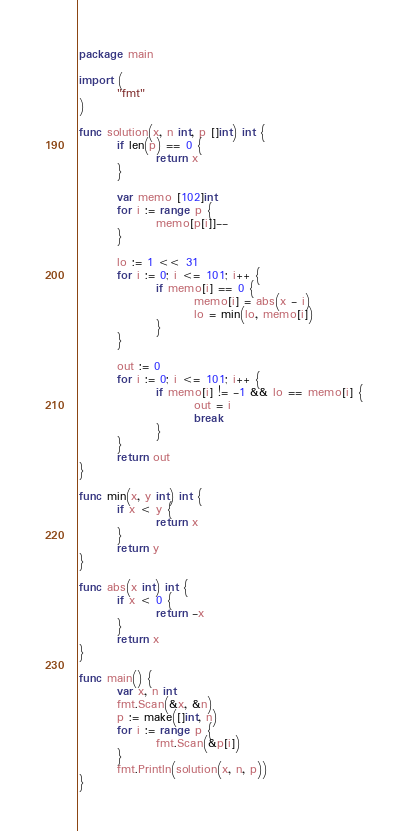<code> <loc_0><loc_0><loc_500><loc_500><_Go_>package main

import (
        "fmt"
)

func solution(x, n int, p []int) int {
        if len(p) == 0 {
                return x
        }

        var memo [102]int
        for i := range p {
                memo[p[i]]--
        }

        lo := 1 << 31
        for i := 0; i <= 101; i++ {
                if memo[i] == 0 {
                        memo[i] = abs(x - i)
                        lo = min(lo, memo[i])
                }
        }

        out := 0
        for i := 0; i <= 101; i++ {
                if memo[i] != -1 && lo == memo[i] {
                        out = i
                        break
                }
        }
        return out
}

func min(x, y int) int {
        if x < y {
                return x
        }
        return y
}

func abs(x int) int {
        if x < 0 {
                return -x
        }
        return x
}

func main() {
        var x, n int
        fmt.Scan(&x, &n)
        p := make([]int, n)
        for i := range p {
                fmt.Scan(&p[i])
        }
        fmt.Println(solution(x, n, p))
}</code> 